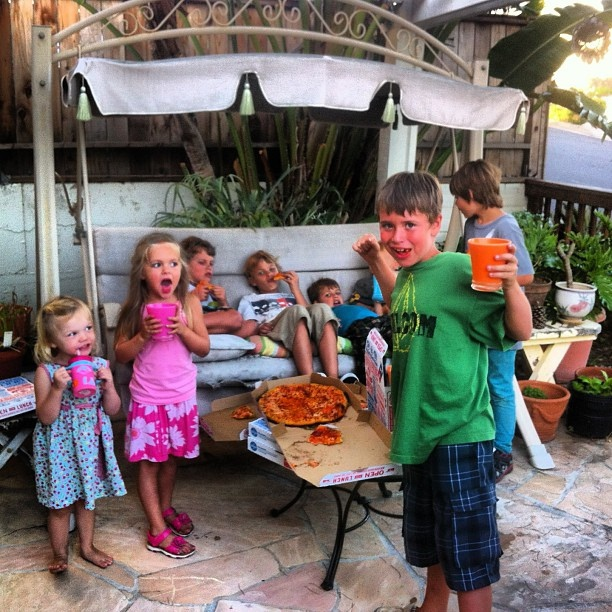Describe the objects in this image and their specific colors. I can see people in black, green, and darkgreen tones, people in black, maroon, and violet tones, people in black, brown, gray, and maroon tones, bench in black, darkgray, and gray tones, and potted plant in black, gray, and darkgreen tones in this image. 